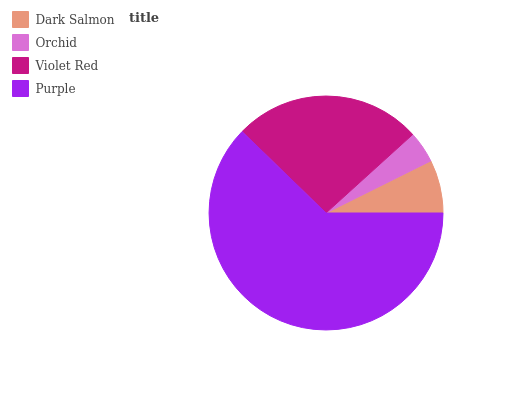Is Orchid the minimum?
Answer yes or no. Yes. Is Purple the maximum?
Answer yes or no. Yes. Is Violet Red the minimum?
Answer yes or no. No. Is Violet Red the maximum?
Answer yes or no. No. Is Violet Red greater than Orchid?
Answer yes or no. Yes. Is Orchid less than Violet Red?
Answer yes or no. Yes. Is Orchid greater than Violet Red?
Answer yes or no. No. Is Violet Red less than Orchid?
Answer yes or no. No. Is Violet Red the high median?
Answer yes or no. Yes. Is Dark Salmon the low median?
Answer yes or no. Yes. Is Dark Salmon the high median?
Answer yes or no. No. Is Orchid the low median?
Answer yes or no. No. 